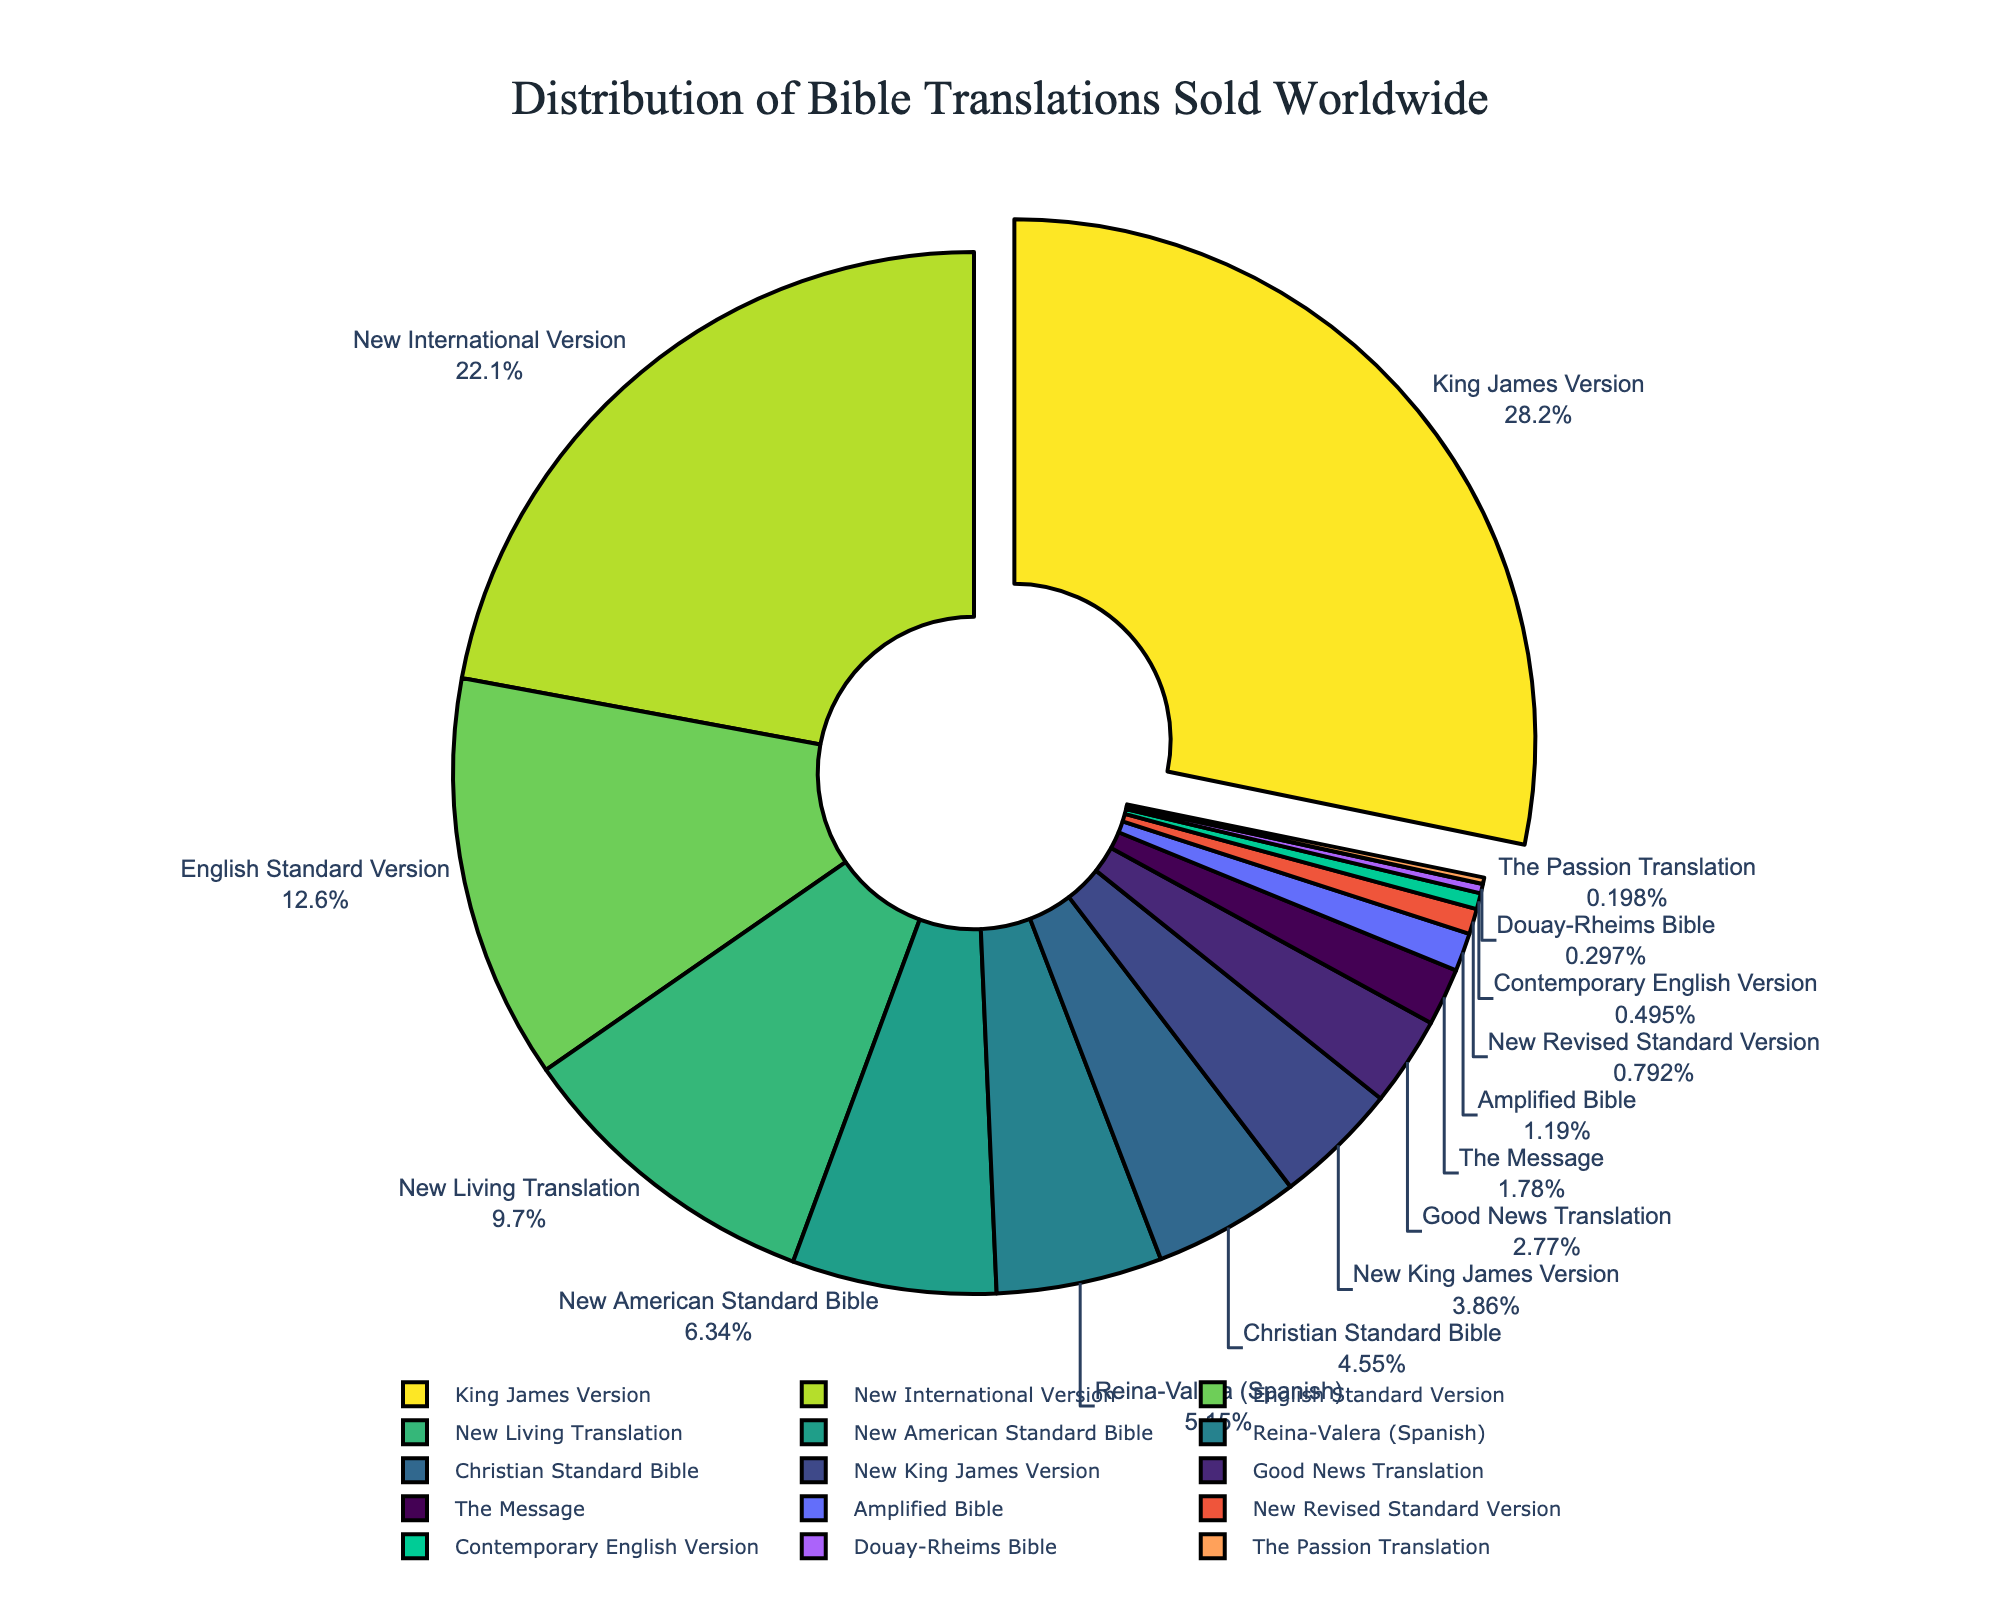Which Bible translation has the highest percentage of sales? The segment that is pulled out slightly from the pie chart corresponds to the King James Version, which has the highest percentage.
Answer: King James Version Which translation has a higher percentage of sales: the New International Version or the New Living Translation? The pie chart shows that the New International Version has a larger segment compared to the New Living Translation.
Answer: New International Version What is the combined percentage of sales for the King James Version and the New International Version? Adding the percentages of the King James Version (28.5%) and the New International Version (22.3%) results in 28.5 + 22.3 = 50.8%.
Answer: 50.8% Which translation has the smallest percentage of sales? The smallest segment in the pie chart belongs to The Passion Translation.
Answer: The Passion Translation How much larger is the percentage of sales for the King James Version compared to the English Standard Version? The King James Version has 28.5% of sales, and the English Standard Version has 12.7%. Subtracting these gives 28.5 - 12.7 = 15.8%.
Answer: 15.8% What is the total percentage of sales for the translations that have less than 5% each? Summing the percentages for New King James Version (3.9%), Good News Translation (2.8%), The Message (1.8%), Amplified Bible (1.2%), New Revised Standard Version (0.8%), Contemporary English Version (0.5%), Douay-Rheims Bible (0.3%), and The Passion Translation (0.2%) gives 3.9 + 2.8 + 1.8 + 1.2 + 0.8 + 0.5 + 0.3 + 0.2 = 11.5%.
Answer: 11.5% Is the percentage of sales for the Christian Standard Bible greater than or equal to the percentage of sales for the Reina-Valera (Spanish) translation? The Christian Standard Bible has 4.6% of sales, while the Reina-Valera (Spanish) has 5.2%. Since 4.6 < 5.2, the answer is no.
Answer: No Among the translations with more than 10% of sales, which one has the lowest percentage? Among the translations with more than 10% (King James Version, New International Version, and English Standard Version), the English Standard Version has the lowest percentage at 12.7%.
Answer: English Standard Version How does the percentage of sales for the New American Standard Bible compare to that of the Christian Standard Bible? The New American Standard Bible has 6.4% and the Christian Standard Bible has 4.6%. Comparing these, 6.4 > 4.6.
Answer: New American Standard Bible has a higher percentage 